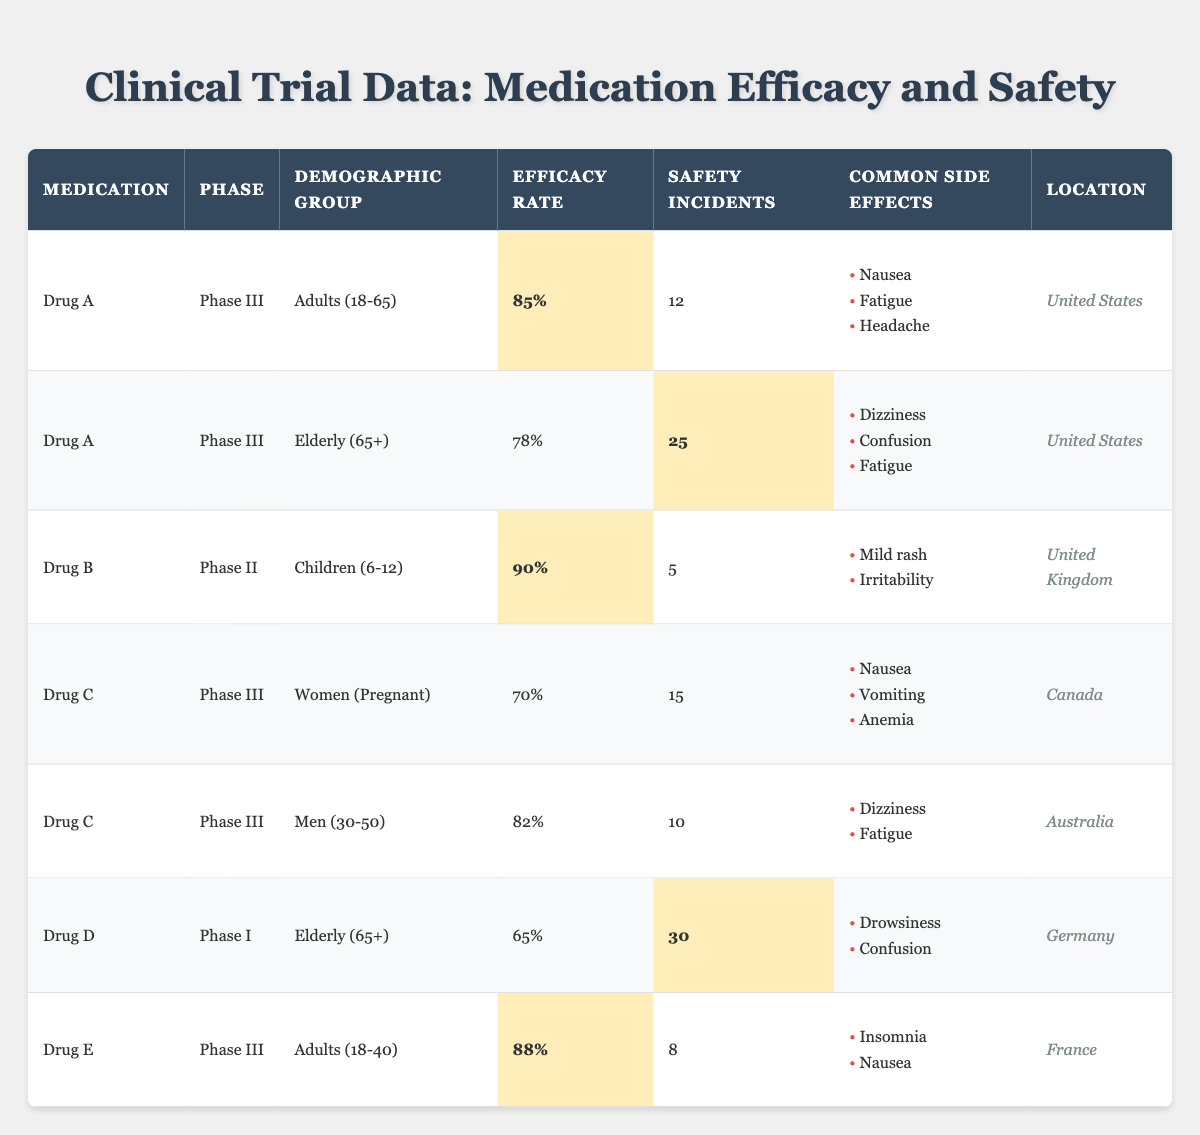What is the efficacy rate of Drug B for children aged 6-12? The table states that Drug B, which is tested in Phase II for the demographic group of children (6-12), has an efficacy rate of 90%.
Answer: 90% How many safety incidents were reported for the elderly demographic group taking Drug A? According to the table, there were 25 safety incidents reported for the elderly (65+) group taking Drug A.
Answer: 25 Which drug has the highest efficacy rate among adults (18-65)? In the table, Drug A shows an efficacy rate of 85% for adults (18-65), while Drug E shows 88% for adults (18-40). Thus, Drug E has the highest efficacy in these demographics.
Answer: Drug E What is the average efficacy rate of Drug C for both demographic groups listed? Drug C has an efficacy rate of 70% for women (pregnant) and 82% for men (30-50). The average is calculated as (70 + 82) / 2 = 76%.
Answer: 76% Are there any common side effects reported for Drug E? The table shows that for Drug E, common side effects include insomnia and nausea, confirming that it has reported side effects.
Answer: Yes What is the total number of safety incidents reported for both elderly groups (Drug A and Drug D)? Drug A reported 25 incidents and Drug D reported 30 incidents. Adding them gives 25 + 30 = 55 safety incidents in total.
Answer: 55 Is there any demographic group where Drug C shows an efficacy rate below 75%? Drug C shows an efficacy rate of 70% for pregnant women, which is below 75%. Therefore, the statement is true.
Answer: Yes Which drug has the lowest efficacy rate, and what is the rate? Examining the table, Drug D has the lowest efficacy rate recorded at 65% for the elderly demographic group.
Answer: Drug D, 65% What percentage of safety incidents were recorded for Drug C compared to Drug A for the same demographic group? For Drug C (women pregnant), there were 15 safety incidents, while for Drug A (adults 18-65) there were 12 incidents. To compare, 15 / 12 = 1.25, indicating a higher incident rate for Drug C.
Answer: 25% more incidents for Drug C Which drug had the most common side effects, and how many side effects are listed? Drug C has three common side effects (nausea, vomiting, anemia) for pregnant women, which is more than the others listed, which mostly have two.
Answer: Drug C, 3 side effects 